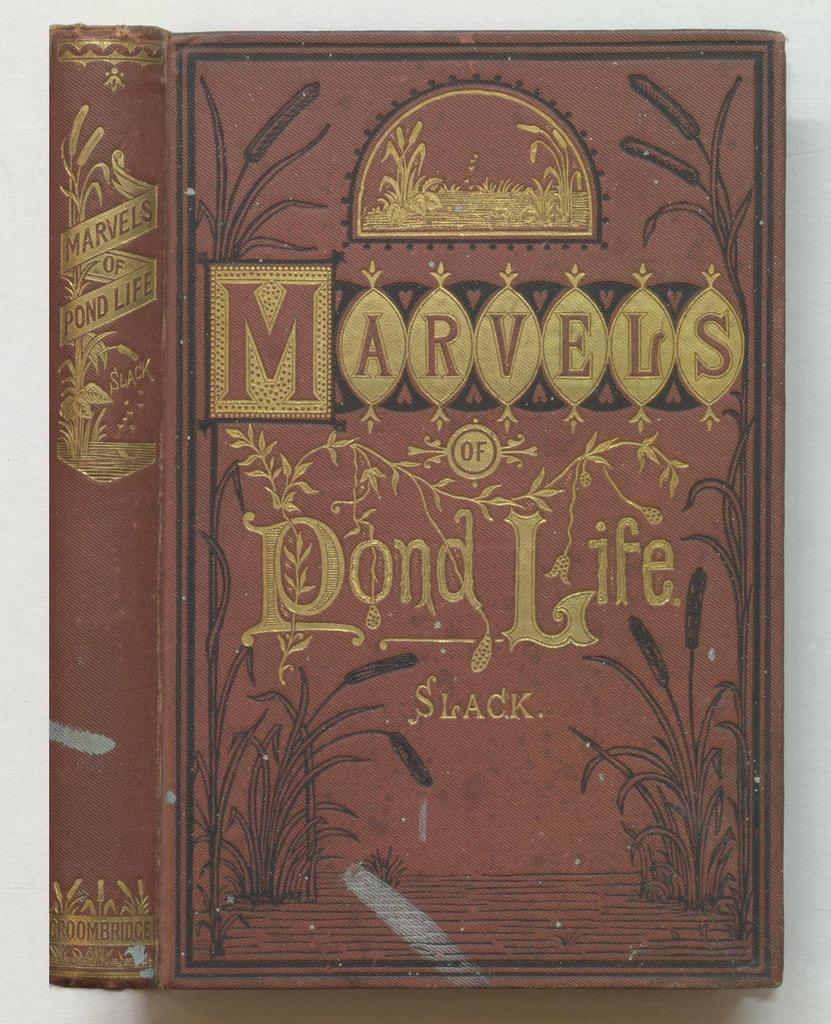Provide a one-sentence caption for the provided image. An old book a bout the marvels of pond life. 